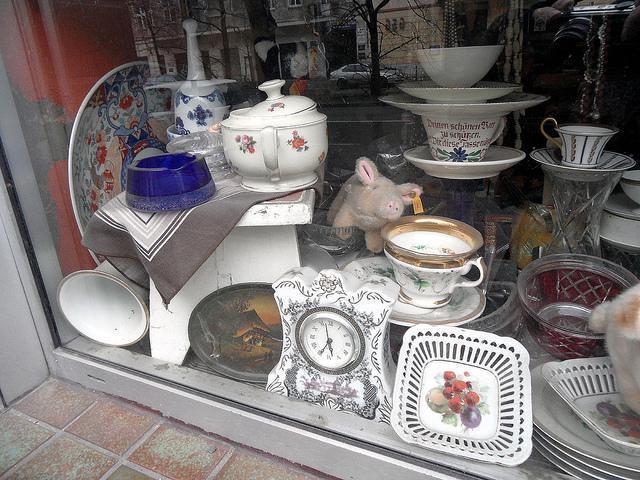How many brand new items will one find in this store?
Select the accurate answer and provide explanation: 'Answer: answer
Rationale: rationale.'
Options: Zero, twenty, six, fifty. Answer: zero.
Rationale: This is an antique store 